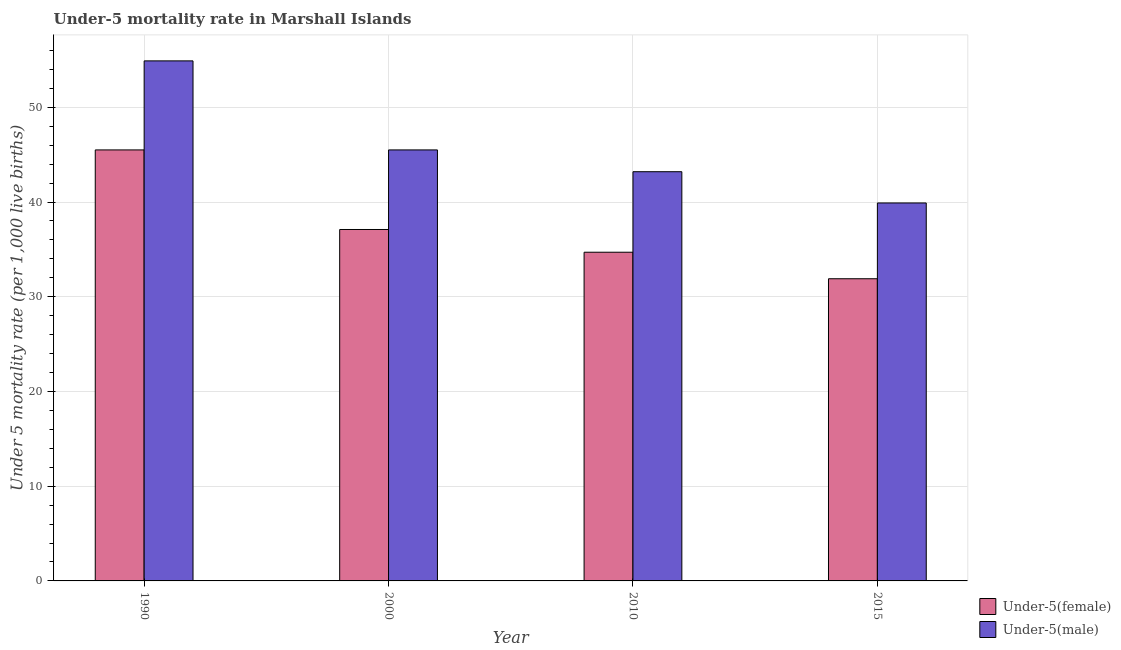How many different coloured bars are there?
Your response must be concise. 2. How many groups of bars are there?
Make the answer very short. 4. Are the number of bars on each tick of the X-axis equal?
Offer a terse response. Yes. How many bars are there on the 2nd tick from the right?
Your response must be concise. 2. What is the label of the 3rd group of bars from the left?
Provide a succinct answer. 2010. In how many cases, is the number of bars for a given year not equal to the number of legend labels?
Provide a succinct answer. 0. What is the under-5 female mortality rate in 2015?
Your answer should be compact. 31.9. Across all years, what is the maximum under-5 male mortality rate?
Make the answer very short. 54.9. Across all years, what is the minimum under-5 female mortality rate?
Keep it short and to the point. 31.9. In which year was the under-5 female mortality rate minimum?
Your answer should be compact. 2015. What is the total under-5 female mortality rate in the graph?
Your answer should be compact. 149.2. What is the difference between the under-5 female mortality rate in 1990 and that in 2010?
Give a very brief answer. 10.8. What is the difference between the under-5 male mortality rate in 1990 and the under-5 female mortality rate in 2010?
Ensure brevity in your answer.  11.7. What is the average under-5 male mortality rate per year?
Your answer should be very brief. 45.88. In the year 2015, what is the difference between the under-5 female mortality rate and under-5 male mortality rate?
Provide a short and direct response. 0. In how many years, is the under-5 male mortality rate greater than 12?
Your answer should be very brief. 4. What is the ratio of the under-5 female mortality rate in 1990 to that in 2010?
Provide a short and direct response. 1.31. Is the difference between the under-5 female mortality rate in 2000 and 2015 greater than the difference between the under-5 male mortality rate in 2000 and 2015?
Offer a terse response. No. What is the difference between the highest and the second highest under-5 female mortality rate?
Your answer should be very brief. 8.4. What does the 2nd bar from the left in 2015 represents?
Keep it short and to the point. Under-5(male). What does the 1st bar from the right in 2000 represents?
Your response must be concise. Under-5(male). How many legend labels are there?
Your answer should be compact. 2. What is the title of the graph?
Keep it short and to the point. Under-5 mortality rate in Marshall Islands. What is the label or title of the Y-axis?
Make the answer very short. Under 5 mortality rate (per 1,0 live births). What is the Under 5 mortality rate (per 1,000 live births) in Under-5(female) in 1990?
Give a very brief answer. 45.5. What is the Under 5 mortality rate (per 1,000 live births) in Under-5(male) in 1990?
Your answer should be compact. 54.9. What is the Under 5 mortality rate (per 1,000 live births) in Under-5(female) in 2000?
Offer a very short reply. 37.1. What is the Under 5 mortality rate (per 1,000 live births) of Under-5(male) in 2000?
Ensure brevity in your answer.  45.5. What is the Under 5 mortality rate (per 1,000 live births) in Under-5(female) in 2010?
Make the answer very short. 34.7. What is the Under 5 mortality rate (per 1,000 live births) of Under-5(male) in 2010?
Your response must be concise. 43.2. What is the Under 5 mortality rate (per 1,000 live births) of Under-5(female) in 2015?
Provide a succinct answer. 31.9. What is the Under 5 mortality rate (per 1,000 live births) of Under-5(male) in 2015?
Your response must be concise. 39.9. Across all years, what is the maximum Under 5 mortality rate (per 1,000 live births) of Under-5(female)?
Offer a terse response. 45.5. Across all years, what is the maximum Under 5 mortality rate (per 1,000 live births) in Under-5(male)?
Make the answer very short. 54.9. Across all years, what is the minimum Under 5 mortality rate (per 1,000 live births) of Under-5(female)?
Keep it short and to the point. 31.9. Across all years, what is the minimum Under 5 mortality rate (per 1,000 live births) in Under-5(male)?
Make the answer very short. 39.9. What is the total Under 5 mortality rate (per 1,000 live births) in Under-5(female) in the graph?
Your answer should be compact. 149.2. What is the total Under 5 mortality rate (per 1,000 live births) in Under-5(male) in the graph?
Make the answer very short. 183.5. What is the difference between the Under 5 mortality rate (per 1,000 live births) in Under-5(male) in 1990 and that in 2000?
Make the answer very short. 9.4. What is the difference between the Under 5 mortality rate (per 1,000 live births) of Under-5(female) in 1990 and that in 2015?
Make the answer very short. 13.6. What is the difference between the Under 5 mortality rate (per 1,000 live births) in Under-5(male) in 1990 and that in 2015?
Offer a very short reply. 15. What is the difference between the Under 5 mortality rate (per 1,000 live births) of Under-5(male) in 2000 and that in 2010?
Offer a terse response. 2.3. What is the difference between the Under 5 mortality rate (per 1,000 live births) in Under-5(male) in 2000 and that in 2015?
Your answer should be very brief. 5.6. What is the difference between the Under 5 mortality rate (per 1,000 live births) in Under-5(female) in 2010 and that in 2015?
Your response must be concise. 2.8. What is the difference between the Under 5 mortality rate (per 1,000 live births) in Under-5(male) in 2010 and that in 2015?
Make the answer very short. 3.3. What is the difference between the Under 5 mortality rate (per 1,000 live births) of Under-5(female) in 1990 and the Under 5 mortality rate (per 1,000 live births) of Under-5(male) in 2000?
Make the answer very short. 0. What is the difference between the Under 5 mortality rate (per 1,000 live births) of Under-5(female) in 1990 and the Under 5 mortality rate (per 1,000 live births) of Under-5(male) in 2015?
Your answer should be very brief. 5.6. What is the difference between the Under 5 mortality rate (per 1,000 live births) of Under-5(female) in 2000 and the Under 5 mortality rate (per 1,000 live births) of Under-5(male) in 2010?
Keep it short and to the point. -6.1. What is the difference between the Under 5 mortality rate (per 1,000 live births) of Under-5(female) in 2000 and the Under 5 mortality rate (per 1,000 live births) of Under-5(male) in 2015?
Your answer should be very brief. -2.8. What is the difference between the Under 5 mortality rate (per 1,000 live births) of Under-5(female) in 2010 and the Under 5 mortality rate (per 1,000 live births) of Under-5(male) in 2015?
Provide a succinct answer. -5.2. What is the average Under 5 mortality rate (per 1,000 live births) in Under-5(female) per year?
Offer a terse response. 37.3. What is the average Under 5 mortality rate (per 1,000 live births) of Under-5(male) per year?
Offer a very short reply. 45.88. In the year 2000, what is the difference between the Under 5 mortality rate (per 1,000 live births) in Under-5(female) and Under 5 mortality rate (per 1,000 live births) in Under-5(male)?
Provide a succinct answer. -8.4. In the year 2010, what is the difference between the Under 5 mortality rate (per 1,000 live births) of Under-5(female) and Under 5 mortality rate (per 1,000 live births) of Under-5(male)?
Your answer should be compact. -8.5. In the year 2015, what is the difference between the Under 5 mortality rate (per 1,000 live births) of Under-5(female) and Under 5 mortality rate (per 1,000 live births) of Under-5(male)?
Offer a terse response. -8. What is the ratio of the Under 5 mortality rate (per 1,000 live births) in Under-5(female) in 1990 to that in 2000?
Keep it short and to the point. 1.23. What is the ratio of the Under 5 mortality rate (per 1,000 live births) of Under-5(male) in 1990 to that in 2000?
Provide a succinct answer. 1.21. What is the ratio of the Under 5 mortality rate (per 1,000 live births) in Under-5(female) in 1990 to that in 2010?
Your answer should be very brief. 1.31. What is the ratio of the Under 5 mortality rate (per 1,000 live births) in Under-5(male) in 1990 to that in 2010?
Your response must be concise. 1.27. What is the ratio of the Under 5 mortality rate (per 1,000 live births) of Under-5(female) in 1990 to that in 2015?
Your response must be concise. 1.43. What is the ratio of the Under 5 mortality rate (per 1,000 live births) in Under-5(male) in 1990 to that in 2015?
Provide a short and direct response. 1.38. What is the ratio of the Under 5 mortality rate (per 1,000 live births) in Under-5(female) in 2000 to that in 2010?
Provide a succinct answer. 1.07. What is the ratio of the Under 5 mortality rate (per 1,000 live births) of Under-5(male) in 2000 to that in 2010?
Keep it short and to the point. 1.05. What is the ratio of the Under 5 mortality rate (per 1,000 live births) of Under-5(female) in 2000 to that in 2015?
Your answer should be compact. 1.16. What is the ratio of the Under 5 mortality rate (per 1,000 live births) in Under-5(male) in 2000 to that in 2015?
Give a very brief answer. 1.14. What is the ratio of the Under 5 mortality rate (per 1,000 live births) in Under-5(female) in 2010 to that in 2015?
Give a very brief answer. 1.09. What is the ratio of the Under 5 mortality rate (per 1,000 live births) of Under-5(male) in 2010 to that in 2015?
Your response must be concise. 1.08. What is the difference between the highest and the second highest Under 5 mortality rate (per 1,000 live births) of Under-5(female)?
Offer a terse response. 8.4. What is the difference between the highest and the second highest Under 5 mortality rate (per 1,000 live births) of Under-5(male)?
Ensure brevity in your answer.  9.4. What is the difference between the highest and the lowest Under 5 mortality rate (per 1,000 live births) in Under-5(female)?
Provide a succinct answer. 13.6. What is the difference between the highest and the lowest Under 5 mortality rate (per 1,000 live births) of Under-5(male)?
Ensure brevity in your answer.  15. 